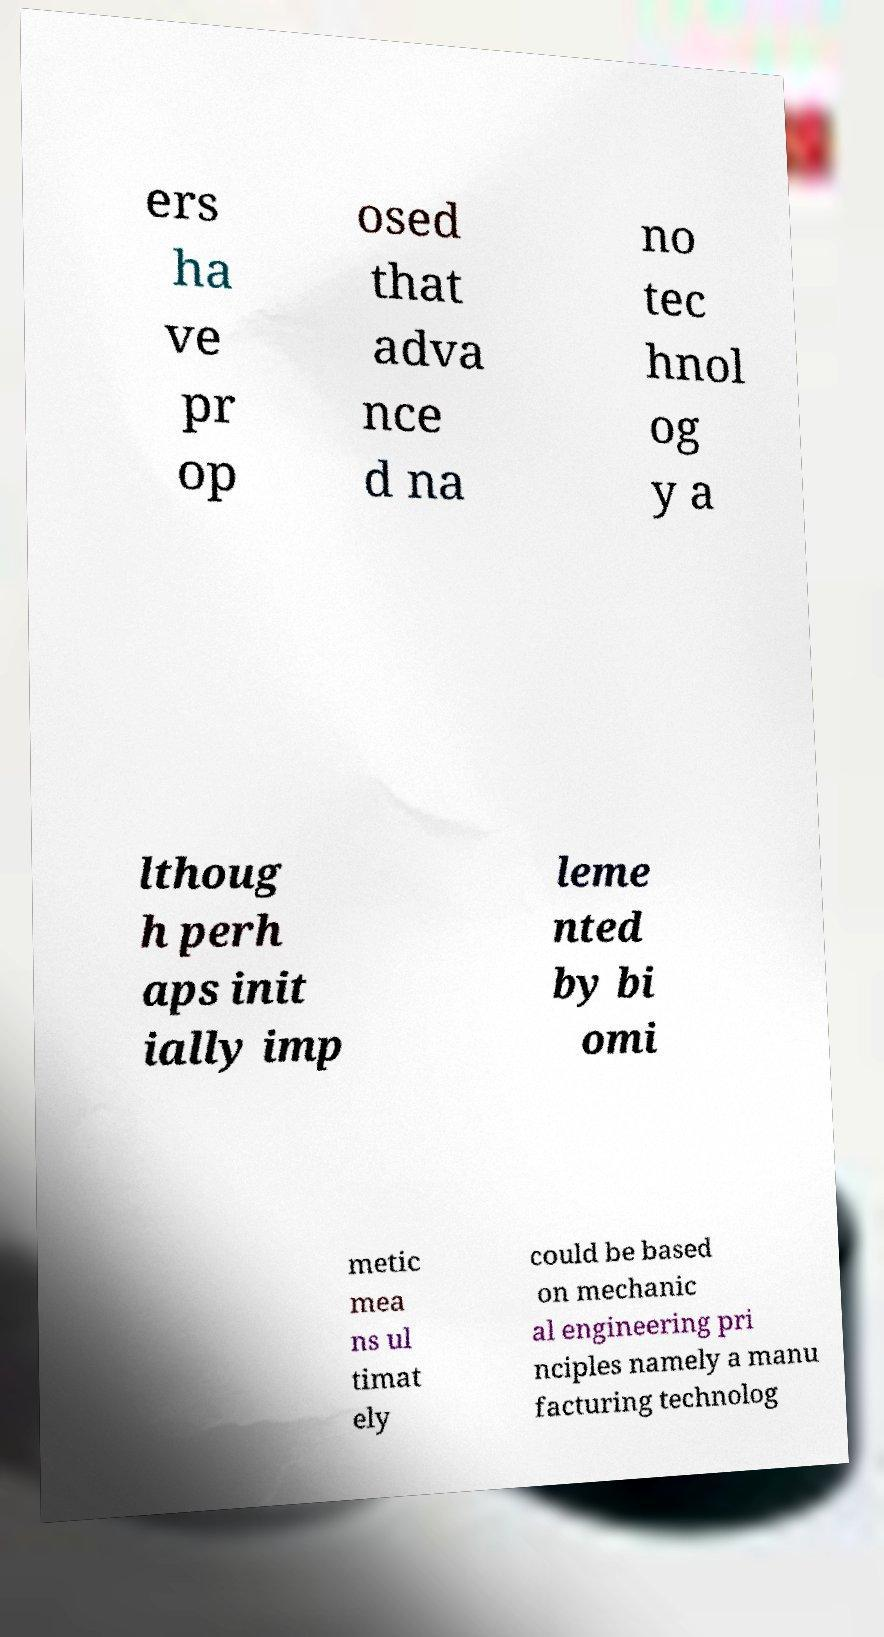For documentation purposes, I need the text within this image transcribed. Could you provide that? ers ha ve pr op osed that adva nce d na no tec hnol og y a lthoug h perh aps init ially imp leme nted by bi omi metic mea ns ul timat ely could be based on mechanic al engineering pri nciples namely a manu facturing technolog 